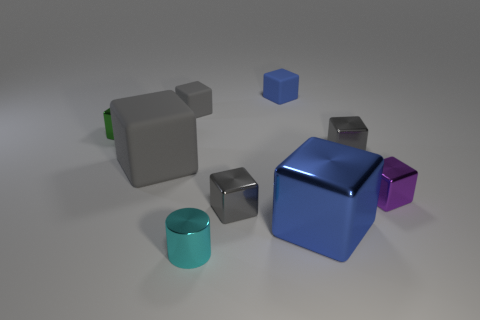Subtract all gray blocks. How many were subtracted if there are2gray blocks left? 2 Subtract all small gray cubes. How many cubes are left? 5 Subtract all blue cubes. How many cubes are left? 6 Subtract 5 cubes. How many cubes are left? 3 Subtract all purple balls. How many gray blocks are left? 4 Add 1 blue shiny blocks. How many objects exist? 10 Subtract all blocks. How many objects are left? 1 Add 5 large blue shiny cubes. How many large blue shiny cubes exist? 6 Subtract 0 red cubes. How many objects are left? 9 Subtract all gray blocks. Subtract all gray cylinders. How many blocks are left? 4 